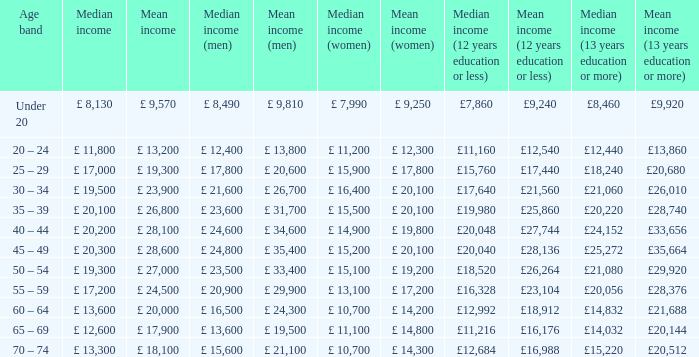Name the median income for age band being under 20 £ 8,130. 